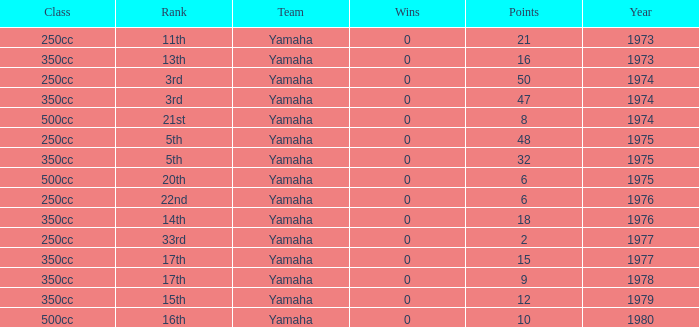How many Points have a Rank of 17th, and Wins larger than 0? 0.0. 